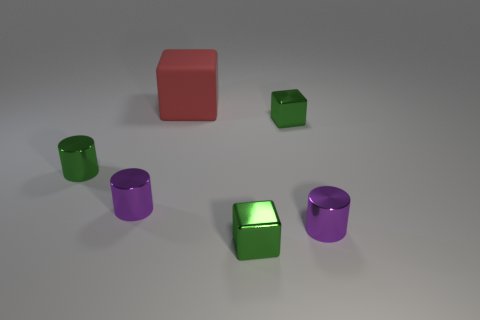Subtract 1 cylinders. How many cylinders are left? 2 Add 2 large red rubber blocks. How many objects exist? 8 Add 6 tiny purple cylinders. How many tiny purple cylinders are left? 8 Add 6 small purple things. How many small purple things exist? 8 Subtract 0 brown cylinders. How many objects are left? 6 Subtract all small green cylinders. Subtract all tiny objects. How many objects are left? 0 